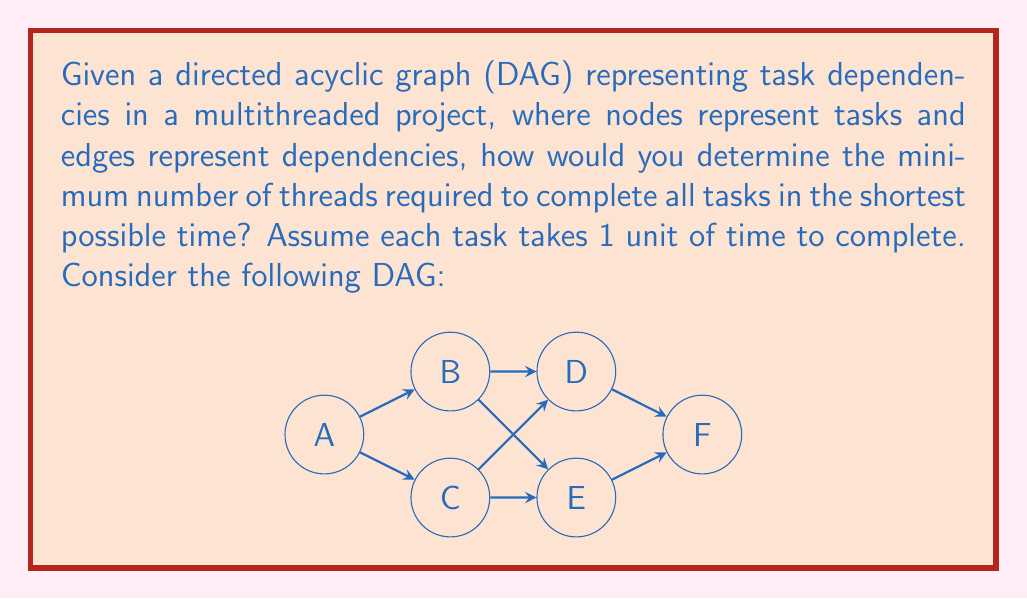What is the answer to this math problem? To solve this problem, we'll use the concept of critical path and parallelism in graph theory:

1) First, we need to find the critical path of the DAG. The critical path is the longest path from the start node to the end node, which determines the minimum time required to complete all tasks.

2) To find the critical path, we'll use the following steps:
   a) Assign earliest start time (EST) to each node, moving forward in the graph.
   b) Assign latest finish time (LFT) to each node, moving backward in the graph.
   c) The nodes where EST = LFT form the critical path.

3) Let's calculate EST for each node:
   A: 0
   B: 1
   C: 1
   D: 2
   E: 2
   F: 3

4) Now, let's calculate LFT for each node (assuming total time is 3):
   F: 3
   D: 2
   E: 2
   B: 1
   C: 1
   A: 0

5) The critical path is A -> B -> D -> F and A -> C -> E -> F, both with length 4.

6) To determine the minimum number of threads, we need to find the maximum number of parallel tasks at any given time step:

   Time 0: A (1 task)
   Time 1: B, C (2 tasks)
   Time 2: D, E (2 tasks)
   Time 3: F (1 task)

7) The maximum number of parallel tasks is 2, which occurs at time steps 1 and 2.

Therefore, the minimum number of threads required to complete all tasks in the shortest possible time (4 time units) is 2.
Answer: The minimum number of threads required is 2. 